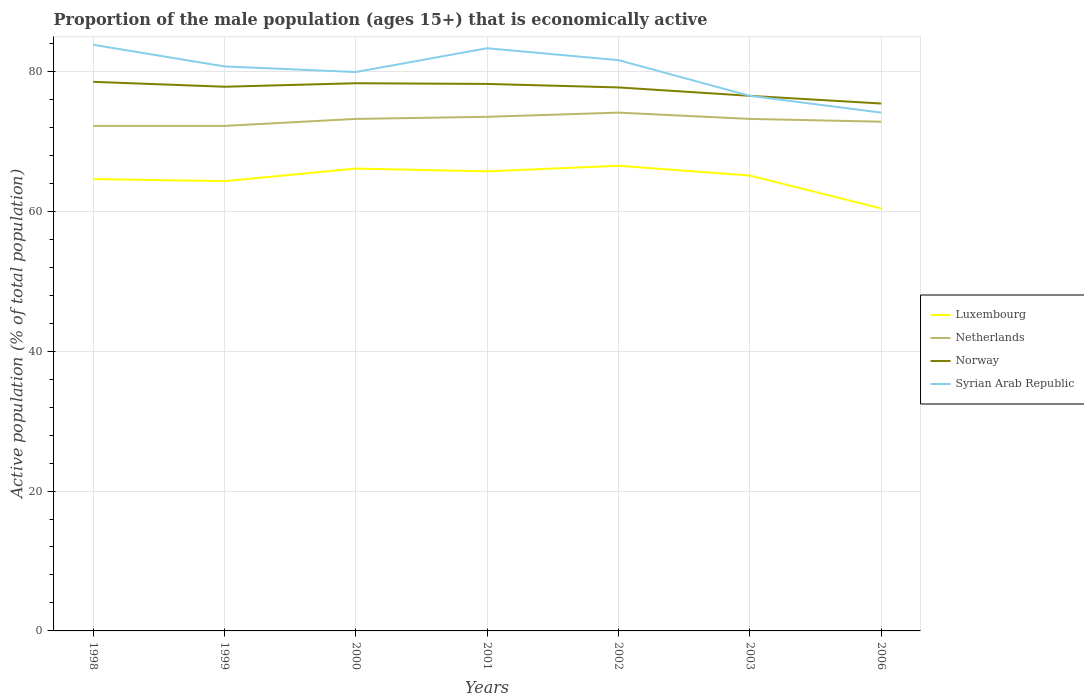How many different coloured lines are there?
Provide a succinct answer. 4. Is the number of lines equal to the number of legend labels?
Your answer should be compact. Yes. Across all years, what is the maximum proportion of the male population that is economically active in Netherlands?
Provide a short and direct response. 72.2. In which year was the proportion of the male population that is economically active in Syrian Arab Republic maximum?
Your response must be concise. 2006. What is the total proportion of the male population that is economically active in Syrian Arab Republic in the graph?
Your response must be concise. -3.4. What is the difference between the highest and the second highest proportion of the male population that is economically active in Luxembourg?
Keep it short and to the point. 6.1. How many lines are there?
Your response must be concise. 4. How many years are there in the graph?
Offer a very short reply. 7. What is the difference between two consecutive major ticks on the Y-axis?
Give a very brief answer. 20. Does the graph contain any zero values?
Offer a terse response. No. Does the graph contain grids?
Offer a terse response. Yes. How many legend labels are there?
Your answer should be compact. 4. What is the title of the graph?
Your answer should be compact. Proportion of the male population (ages 15+) that is economically active. Does "Palau" appear as one of the legend labels in the graph?
Offer a terse response. No. What is the label or title of the Y-axis?
Make the answer very short. Active population (% of total population). What is the Active population (% of total population) in Luxembourg in 1998?
Offer a very short reply. 64.6. What is the Active population (% of total population) of Netherlands in 1998?
Offer a very short reply. 72.2. What is the Active population (% of total population) of Norway in 1998?
Your response must be concise. 78.5. What is the Active population (% of total population) of Syrian Arab Republic in 1998?
Make the answer very short. 83.8. What is the Active population (% of total population) of Luxembourg in 1999?
Keep it short and to the point. 64.3. What is the Active population (% of total population) of Netherlands in 1999?
Ensure brevity in your answer.  72.2. What is the Active population (% of total population) in Norway in 1999?
Ensure brevity in your answer.  77.8. What is the Active population (% of total population) of Syrian Arab Republic in 1999?
Make the answer very short. 80.7. What is the Active population (% of total population) in Luxembourg in 2000?
Make the answer very short. 66.1. What is the Active population (% of total population) of Netherlands in 2000?
Your answer should be compact. 73.2. What is the Active population (% of total population) in Norway in 2000?
Offer a terse response. 78.3. What is the Active population (% of total population) of Syrian Arab Republic in 2000?
Your response must be concise. 79.9. What is the Active population (% of total population) of Luxembourg in 2001?
Give a very brief answer. 65.7. What is the Active population (% of total population) of Netherlands in 2001?
Ensure brevity in your answer.  73.5. What is the Active population (% of total population) of Norway in 2001?
Make the answer very short. 78.2. What is the Active population (% of total population) of Syrian Arab Republic in 2001?
Your response must be concise. 83.3. What is the Active population (% of total population) in Luxembourg in 2002?
Your answer should be very brief. 66.5. What is the Active population (% of total population) of Netherlands in 2002?
Ensure brevity in your answer.  74.1. What is the Active population (% of total population) of Norway in 2002?
Ensure brevity in your answer.  77.7. What is the Active population (% of total population) in Syrian Arab Republic in 2002?
Your response must be concise. 81.6. What is the Active population (% of total population) in Luxembourg in 2003?
Your answer should be compact. 65.1. What is the Active population (% of total population) in Netherlands in 2003?
Give a very brief answer. 73.2. What is the Active population (% of total population) in Norway in 2003?
Your response must be concise. 76.5. What is the Active population (% of total population) of Syrian Arab Republic in 2003?
Offer a very short reply. 76.5. What is the Active population (% of total population) in Luxembourg in 2006?
Ensure brevity in your answer.  60.4. What is the Active population (% of total population) of Netherlands in 2006?
Your answer should be very brief. 72.8. What is the Active population (% of total population) in Norway in 2006?
Your answer should be very brief. 75.4. What is the Active population (% of total population) in Syrian Arab Republic in 2006?
Ensure brevity in your answer.  74.1. Across all years, what is the maximum Active population (% of total population) of Luxembourg?
Ensure brevity in your answer.  66.5. Across all years, what is the maximum Active population (% of total population) of Netherlands?
Provide a short and direct response. 74.1. Across all years, what is the maximum Active population (% of total population) of Norway?
Provide a short and direct response. 78.5. Across all years, what is the maximum Active population (% of total population) of Syrian Arab Republic?
Keep it short and to the point. 83.8. Across all years, what is the minimum Active population (% of total population) of Luxembourg?
Offer a very short reply. 60.4. Across all years, what is the minimum Active population (% of total population) of Netherlands?
Keep it short and to the point. 72.2. Across all years, what is the minimum Active population (% of total population) of Norway?
Give a very brief answer. 75.4. Across all years, what is the minimum Active population (% of total population) of Syrian Arab Republic?
Offer a terse response. 74.1. What is the total Active population (% of total population) in Luxembourg in the graph?
Your answer should be compact. 452.7. What is the total Active population (% of total population) in Netherlands in the graph?
Offer a very short reply. 511.2. What is the total Active population (% of total population) in Norway in the graph?
Your answer should be compact. 542.4. What is the total Active population (% of total population) in Syrian Arab Republic in the graph?
Provide a short and direct response. 559.9. What is the difference between the Active population (% of total population) in Luxembourg in 1998 and that in 1999?
Provide a succinct answer. 0.3. What is the difference between the Active population (% of total population) of Netherlands in 1998 and that in 1999?
Keep it short and to the point. 0. What is the difference between the Active population (% of total population) in Syrian Arab Republic in 1998 and that in 1999?
Provide a short and direct response. 3.1. What is the difference between the Active population (% of total population) in Luxembourg in 1998 and that in 2000?
Offer a very short reply. -1.5. What is the difference between the Active population (% of total population) of Netherlands in 1998 and that in 2000?
Offer a very short reply. -1. What is the difference between the Active population (% of total population) in Luxembourg in 1998 and that in 2001?
Your response must be concise. -1.1. What is the difference between the Active population (% of total population) in Netherlands in 1998 and that in 2001?
Your response must be concise. -1.3. What is the difference between the Active population (% of total population) of Norway in 1998 and that in 2001?
Your response must be concise. 0.3. What is the difference between the Active population (% of total population) of Luxembourg in 1998 and that in 2002?
Make the answer very short. -1.9. What is the difference between the Active population (% of total population) in Netherlands in 1998 and that in 2002?
Offer a very short reply. -1.9. What is the difference between the Active population (% of total population) of Norway in 1998 and that in 2002?
Keep it short and to the point. 0.8. What is the difference between the Active population (% of total population) of Netherlands in 1998 and that in 2003?
Provide a succinct answer. -1. What is the difference between the Active population (% of total population) in Syrian Arab Republic in 1998 and that in 2003?
Your response must be concise. 7.3. What is the difference between the Active population (% of total population) in Netherlands in 1998 and that in 2006?
Offer a very short reply. -0.6. What is the difference between the Active population (% of total population) in Norway in 1998 and that in 2006?
Your response must be concise. 3.1. What is the difference between the Active population (% of total population) of Netherlands in 1999 and that in 2000?
Your answer should be compact. -1. What is the difference between the Active population (% of total population) in Syrian Arab Republic in 1999 and that in 2000?
Offer a terse response. 0.8. What is the difference between the Active population (% of total population) of Luxembourg in 1999 and that in 2001?
Your answer should be very brief. -1.4. What is the difference between the Active population (% of total population) in Netherlands in 1999 and that in 2001?
Offer a very short reply. -1.3. What is the difference between the Active population (% of total population) of Syrian Arab Republic in 1999 and that in 2001?
Your response must be concise. -2.6. What is the difference between the Active population (% of total population) of Netherlands in 1999 and that in 2002?
Give a very brief answer. -1.9. What is the difference between the Active population (% of total population) in Norway in 1999 and that in 2002?
Offer a very short reply. 0.1. What is the difference between the Active population (% of total population) in Netherlands in 1999 and that in 2003?
Offer a terse response. -1. What is the difference between the Active population (% of total population) of Syrian Arab Republic in 1999 and that in 2003?
Provide a succinct answer. 4.2. What is the difference between the Active population (% of total population) in Netherlands in 1999 and that in 2006?
Provide a succinct answer. -0.6. What is the difference between the Active population (% of total population) of Norway in 1999 and that in 2006?
Your answer should be compact. 2.4. What is the difference between the Active population (% of total population) in Syrian Arab Republic in 1999 and that in 2006?
Make the answer very short. 6.6. What is the difference between the Active population (% of total population) in Luxembourg in 2000 and that in 2001?
Offer a very short reply. 0.4. What is the difference between the Active population (% of total population) of Netherlands in 2000 and that in 2001?
Ensure brevity in your answer.  -0.3. What is the difference between the Active population (% of total population) in Norway in 2000 and that in 2001?
Your answer should be compact. 0.1. What is the difference between the Active population (% of total population) in Syrian Arab Republic in 2000 and that in 2001?
Ensure brevity in your answer.  -3.4. What is the difference between the Active population (% of total population) of Luxembourg in 2000 and that in 2002?
Keep it short and to the point. -0.4. What is the difference between the Active population (% of total population) in Netherlands in 2000 and that in 2002?
Offer a terse response. -0.9. What is the difference between the Active population (% of total population) in Syrian Arab Republic in 2000 and that in 2002?
Provide a short and direct response. -1.7. What is the difference between the Active population (% of total population) in Norway in 2000 and that in 2003?
Make the answer very short. 1.8. What is the difference between the Active population (% of total population) in Syrian Arab Republic in 2000 and that in 2003?
Ensure brevity in your answer.  3.4. What is the difference between the Active population (% of total population) of Syrian Arab Republic in 2000 and that in 2006?
Keep it short and to the point. 5.8. What is the difference between the Active population (% of total population) of Luxembourg in 2001 and that in 2002?
Offer a terse response. -0.8. What is the difference between the Active population (% of total population) in Luxembourg in 2001 and that in 2003?
Offer a terse response. 0.6. What is the difference between the Active population (% of total population) of Netherlands in 2001 and that in 2003?
Your answer should be very brief. 0.3. What is the difference between the Active population (% of total population) of Syrian Arab Republic in 2001 and that in 2003?
Your answer should be very brief. 6.8. What is the difference between the Active population (% of total population) of Luxembourg in 2001 and that in 2006?
Your answer should be very brief. 5.3. What is the difference between the Active population (% of total population) of Netherlands in 2001 and that in 2006?
Offer a very short reply. 0.7. What is the difference between the Active population (% of total population) of Syrian Arab Republic in 2001 and that in 2006?
Your answer should be compact. 9.2. What is the difference between the Active population (% of total population) in Netherlands in 2002 and that in 2003?
Offer a terse response. 0.9. What is the difference between the Active population (% of total population) in Norway in 2002 and that in 2003?
Ensure brevity in your answer.  1.2. What is the difference between the Active population (% of total population) of Luxembourg in 2002 and that in 2006?
Offer a very short reply. 6.1. What is the difference between the Active population (% of total population) in Netherlands in 2002 and that in 2006?
Your answer should be compact. 1.3. What is the difference between the Active population (% of total population) in Luxembourg in 2003 and that in 2006?
Make the answer very short. 4.7. What is the difference between the Active population (% of total population) of Syrian Arab Republic in 2003 and that in 2006?
Your answer should be very brief. 2.4. What is the difference between the Active population (% of total population) of Luxembourg in 1998 and the Active population (% of total population) of Norway in 1999?
Ensure brevity in your answer.  -13.2. What is the difference between the Active population (% of total population) of Luxembourg in 1998 and the Active population (% of total population) of Syrian Arab Republic in 1999?
Offer a very short reply. -16.1. What is the difference between the Active population (% of total population) in Netherlands in 1998 and the Active population (% of total population) in Syrian Arab Republic in 1999?
Give a very brief answer. -8.5. What is the difference between the Active population (% of total population) of Luxembourg in 1998 and the Active population (% of total population) of Norway in 2000?
Offer a very short reply. -13.7. What is the difference between the Active population (% of total population) in Luxembourg in 1998 and the Active population (% of total population) in Syrian Arab Republic in 2000?
Make the answer very short. -15.3. What is the difference between the Active population (% of total population) in Netherlands in 1998 and the Active population (% of total population) in Norway in 2000?
Your answer should be compact. -6.1. What is the difference between the Active population (% of total population) of Norway in 1998 and the Active population (% of total population) of Syrian Arab Republic in 2000?
Ensure brevity in your answer.  -1.4. What is the difference between the Active population (% of total population) in Luxembourg in 1998 and the Active population (% of total population) in Norway in 2001?
Offer a very short reply. -13.6. What is the difference between the Active population (% of total population) of Luxembourg in 1998 and the Active population (% of total population) of Syrian Arab Republic in 2001?
Ensure brevity in your answer.  -18.7. What is the difference between the Active population (% of total population) in Norway in 1998 and the Active population (% of total population) in Syrian Arab Republic in 2001?
Provide a succinct answer. -4.8. What is the difference between the Active population (% of total population) of Netherlands in 1998 and the Active population (% of total population) of Syrian Arab Republic in 2002?
Provide a short and direct response. -9.4. What is the difference between the Active population (% of total population) in Norway in 1998 and the Active population (% of total population) in Syrian Arab Republic in 2002?
Ensure brevity in your answer.  -3.1. What is the difference between the Active population (% of total population) of Luxembourg in 1998 and the Active population (% of total population) of Netherlands in 2003?
Your answer should be compact. -8.6. What is the difference between the Active population (% of total population) in Luxembourg in 1998 and the Active population (% of total population) in Norway in 2003?
Offer a terse response. -11.9. What is the difference between the Active population (% of total population) of Netherlands in 1998 and the Active population (% of total population) of Norway in 2006?
Provide a short and direct response. -3.2. What is the difference between the Active population (% of total population) of Netherlands in 1998 and the Active population (% of total population) of Syrian Arab Republic in 2006?
Your response must be concise. -1.9. What is the difference between the Active population (% of total population) of Luxembourg in 1999 and the Active population (% of total population) of Norway in 2000?
Your answer should be compact. -14. What is the difference between the Active population (% of total population) of Luxembourg in 1999 and the Active population (% of total population) of Syrian Arab Republic in 2000?
Your response must be concise. -15.6. What is the difference between the Active population (% of total population) of Netherlands in 1999 and the Active population (% of total population) of Norway in 2000?
Provide a short and direct response. -6.1. What is the difference between the Active population (% of total population) of Netherlands in 1999 and the Active population (% of total population) of Syrian Arab Republic in 2000?
Offer a very short reply. -7.7. What is the difference between the Active population (% of total population) of Norway in 1999 and the Active population (% of total population) of Syrian Arab Republic in 2000?
Make the answer very short. -2.1. What is the difference between the Active population (% of total population) in Luxembourg in 1999 and the Active population (% of total population) in Netherlands in 2001?
Your answer should be compact. -9.2. What is the difference between the Active population (% of total population) of Luxembourg in 1999 and the Active population (% of total population) of Norway in 2001?
Make the answer very short. -13.9. What is the difference between the Active population (% of total population) in Luxembourg in 1999 and the Active population (% of total population) in Syrian Arab Republic in 2001?
Offer a terse response. -19. What is the difference between the Active population (% of total population) in Netherlands in 1999 and the Active population (% of total population) in Norway in 2001?
Provide a succinct answer. -6. What is the difference between the Active population (% of total population) in Norway in 1999 and the Active population (% of total population) in Syrian Arab Republic in 2001?
Ensure brevity in your answer.  -5.5. What is the difference between the Active population (% of total population) of Luxembourg in 1999 and the Active population (% of total population) of Norway in 2002?
Keep it short and to the point. -13.4. What is the difference between the Active population (% of total population) of Luxembourg in 1999 and the Active population (% of total population) of Syrian Arab Republic in 2002?
Offer a terse response. -17.3. What is the difference between the Active population (% of total population) in Netherlands in 1999 and the Active population (% of total population) in Syrian Arab Republic in 2002?
Make the answer very short. -9.4. What is the difference between the Active population (% of total population) in Netherlands in 1999 and the Active population (% of total population) in Syrian Arab Republic in 2003?
Ensure brevity in your answer.  -4.3. What is the difference between the Active population (% of total population) of Norway in 1999 and the Active population (% of total population) of Syrian Arab Republic in 2003?
Offer a terse response. 1.3. What is the difference between the Active population (% of total population) of Netherlands in 1999 and the Active population (% of total population) of Norway in 2006?
Provide a short and direct response. -3.2. What is the difference between the Active population (% of total population) of Netherlands in 1999 and the Active population (% of total population) of Syrian Arab Republic in 2006?
Make the answer very short. -1.9. What is the difference between the Active population (% of total population) of Luxembourg in 2000 and the Active population (% of total population) of Norway in 2001?
Provide a short and direct response. -12.1. What is the difference between the Active population (% of total population) of Luxembourg in 2000 and the Active population (% of total population) of Syrian Arab Republic in 2001?
Provide a short and direct response. -17.2. What is the difference between the Active population (% of total population) of Netherlands in 2000 and the Active population (% of total population) of Norway in 2001?
Make the answer very short. -5. What is the difference between the Active population (% of total population) in Norway in 2000 and the Active population (% of total population) in Syrian Arab Republic in 2001?
Offer a terse response. -5. What is the difference between the Active population (% of total population) in Luxembourg in 2000 and the Active population (% of total population) in Netherlands in 2002?
Offer a terse response. -8. What is the difference between the Active population (% of total population) in Luxembourg in 2000 and the Active population (% of total population) in Norway in 2002?
Your answer should be compact. -11.6. What is the difference between the Active population (% of total population) in Luxembourg in 2000 and the Active population (% of total population) in Syrian Arab Republic in 2002?
Provide a short and direct response. -15.5. What is the difference between the Active population (% of total population) in Norway in 2000 and the Active population (% of total population) in Syrian Arab Republic in 2002?
Offer a terse response. -3.3. What is the difference between the Active population (% of total population) of Norway in 2000 and the Active population (% of total population) of Syrian Arab Republic in 2003?
Offer a terse response. 1.8. What is the difference between the Active population (% of total population) of Luxembourg in 2000 and the Active population (% of total population) of Netherlands in 2006?
Make the answer very short. -6.7. What is the difference between the Active population (% of total population) of Netherlands in 2000 and the Active population (% of total population) of Norway in 2006?
Offer a very short reply. -2.2. What is the difference between the Active population (% of total population) in Netherlands in 2000 and the Active population (% of total population) in Syrian Arab Republic in 2006?
Offer a terse response. -0.9. What is the difference between the Active population (% of total population) in Norway in 2000 and the Active population (% of total population) in Syrian Arab Republic in 2006?
Your answer should be very brief. 4.2. What is the difference between the Active population (% of total population) in Luxembourg in 2001 and the Active population (% of total population) in Netherlands in 2002?
Keep it short and to the point. -8.4. What is the difference between the Active population (% of total population) in Luxembourg in 2001 and the Active population (% of total population) in Norway in 2002?
Give a very brief answer. -12. What is the difference between the Active population (% of total population) of Luxembourg in 2001 and the Active population (% of total population) of Syrian Arab Republic in 2002?
Your answer should be very brief. -15.9. What is the difference between the Active population (% of total population) in Netherlands in 2001 and the Active population (% of total population) in Norway in 2002?
Your response must be concise. -4.2. What is the difference between the Active population (% of total population) of Netherlands in 2001 and the Active population (% of total population) of Syrian Arab Republic in 2002?
Your answer should be compact. -8.1. What is the difference between the Active population (% of total population) of Luxembourg in 2001 and the Active population (% of total population) of Netherlands in 2003?
Offer a very short reply. -7.5. What is the difference between the Active population (% of total population) in Luxembourg in 2001 and the Active population (% of total population) in Norway in 2003?
Your response must be concise. -10.8. What is the difference between the Active population (% of total population) of Luxembourg in 2001 and the Active population (% of total population) of Syrian Arab Republic in 2003?
Provide a succinct answer. -10.8. What is the difference between the Active population (% of total population) in Norway in 2001 and the Active population (% of total population) in Syrian Arab Republic in 2003?
Your answer should be very brief. 1.7. What is the difference between the Active population (% of total population) of Luxembourg in 2001 and the Active population (% of total population) of Norway in 2006?
Offer a terse response. -9.7. What is the difference between the Active population (% of total population) in Luxembourg in 2002 and the Active population (% of total population) in Norway in 2003?
Keep it short and to the point. -10. What is the difference between the Active population (% of total population) of Luxembourg in 2002 and the Active population (% of total population) of Syrian Arab Republic in 2003?
Give a very brief answer. -10. What is the difference between the Active population (% of total population) in Luxembourg in 2002 and the Active population (% of total population) in Netherlands in 2006?
Your response must be concise. -6.3. What is the difference between the Active population (% of total population) of Luxembourg in 2002 and the Active population (% of total population) of Norway in 2006?
Your answer should be very brief. -8.9. What is the difference between the Active population (% of total population) of Netherlands in 2002 and the Active population (% of total population) of Norway in 2006?
Your answer should be compact. -1.3. What is the difference between the Active population (% of total population) of Norway in 2002 and the Active population (% of total population) of Syrian Arab Republic in 2006?
Your answer should be compact. 3.6. What is the difference between the Active population (% of total population) in Luxembourg in 2003 and the Active population (% of total population) in Netherlands in 2006?
Keep it short and to the point. -7.7. What is the difference between the Active population (% of total population) of Luxembourg in 2003 and the Active population (% of total population) of Syrian Arab Republic in 2006?
Provide a short and direct response. -9. What is the difference between the Active population (% of total population) of Norway in 2003 and the Active population (% of total population) of Syrian Arab Republic in 2006?
Make the answer very short. 2.4. What is the average Active population (% of total population) of Luxembourg per year?
Keep it short and to the point. 64.67. What is the average Active population (% of total population) of Netherlands per year?
Keep it short and to the point. 73.03. What is the average Active population (% of total population) in Norway per year?
Provide a short and direct response. 77.49. What is the average Active population (% of total population) of Syrian Arab Republic per year?
Provide a short and direct response. 79.99. In the year 1998, what is the difference between the Active population (% of total population) in Luxembourg and Active population (% of total population) in Netherlands?
Your answer should be compact. -7.6. In the year 1998, what is the difference between the Active population (% of total population) in Luxembourg and Active population (% of total population) in Syrian Arab Republic?
Your response must be concise. -19.2. In the year 1998, what is the difference between the Active population (% of total population) in Netherlands and Active population (% of total population) in Norway?
Your answer should be very brief. -6.3. In the year 1999, what is the difference between the Active population (% of total population) of Luxembourg and Active population (% of total population) of Norway?
Make the answer very short. -13.5. In the year 1999, what is the difference between the Active population (% of total population) in Luxembourg and Active population (% of total population) in Syrian Arab Republic?
Make the answer very short. -16.4. In the year 2000, what is the difference between the Active population (% of total population) in Luxembourg and Active population (% of total population) in Netherlands?
Ensure brevity in your answer.  -7.1. In the year 2000, what is the difference between the Active population (% of total population) in Norway and Active population (% of total population) in Syrian Arab Republic?
Give a very brief answer. -1.6. In the year 2001, what is the difference between the Active population (% of total population) of Luxembourg and Active population (% of total population) of Syrian Arab Republic?
Make the answer very short. -17.6. In the year 2001, what is the difference between the Active population (% of total population) in Netherlands and Active population (% of total population) in Norway?
Offer a very short reply. -4.7. In the year 2001, what is the difference between the Active population (% of total population) in Netherlands and Active population (% of total population) in Syrian Arab Republic?
Keep it short and to the point. -9.8. In the year 2002, what is the difference between the Active population (% of total population) in Luxembourg and Active population (% of total population) in Netherlands?
Ensure brevity in your answer.  -7.6. In the year 2002, what is the difference between the Active population (% of total population) in Luxembourg and Active population (% of total population) in Norway?
Make the answer very short. -11.2. In the year 2002, what is the difference between the Active population (% of total population) of Luxembourg and Active population (% of total population) of Syrian Arab Republic?
Your response must be concise. -15.1. In the year 2002, what is the difference between the Active population (% of total population) in Netherlands and Active population (% of total population) in Norway?
Provide a succinct answer. -3.6. In the year 2002, what is the difference between the Active population (% of total population) of Netherlands and Active population (% of total population) of Syrian Arab Republic?
Your answer should be compact. -7.5. In the year 2003, what is the difference between the Active population (% of total population) in Netherlands and Active population (% of total population) in Norway?
Provide a succinct answer. -3.3. In the year 2003, what is the difference between the Active population (% of total population) of Norway and Active population (% of total population) of Syrian Arab Republic?
Keep it short and to the point. 0. In the year 2006, what is the difference between the Active population (% of total population) in Luxembourg and Active population (% of total population) in Norway?
Keep it short and to the point. -15. In the year 2006, what is the difference between the Active population (% of total population) of Luxembourg and Active population (% of total population) of Syrian Arab Republic?
Ensure brevity in your answer.  -13.7. In the year 2006, what is the difference between the Active population (% of total population) in Netherlands and Active population (% of total population) in Syrian Arab Republic?
Offer a very short reply. -1.3. In the year 2006, what is the difference between the Active population (% of total population) of Norway and Active population (% of total population) of Syrian Arab Republic?
Give a very brief answer. 1.3. What is the ratio of the Active population (% of total population) in Syrian Arab Republic in 1998 to that in 1999?
Provide a succinct answer. 1.04. What is the ratio of the Active population (% of total population) of Luxembourg in 1998 to that in 2000?
Keep it short and to the point. 0.98. What is the ratio of the Active population (% of total population) in Netherlands in 1998 to that in 2000?
Your answer should be very brief. 0.99. What is the ratio of the Active population (% of total population) in Norway in 1998 to that in 2000?
Give a very brief answer. 1. What is the ratio of the Active population (% of total population) in Syrian Arab Republic in 1998 to that in 2000?
Offer a terse response. 1.05. What is the ratio of the Active population (% of total population) of Luxembourg in 1998 to that in 2001?
Your response must be concise. 0.98. What is the ratio of the Active population (% of total population) of Netherlands in 1998 to that in 2001?
Give a very brief answer. 0.98. What is the ratio of the Active population (% of total population) in Norway in 1998 to that in 2001?
Give a very brief answer. 1. What is the ratio of the Active population (% of total population) of Luxembourg in 1998 to that in 2002?
Your response must be concise. 0.97. What is the ratio of the Active population (% of total population) of Netherlands in 1998 to that in 2002?
Your response must be concise. 0.97. What is the ratio of the Active population (% of total population) in Norway in 1998 to that in 2002?
Provide a succinct answer. 1.01. What is the ratio of the Active population (% of total population) in Luxembourg in 1998 to that in 2003?
Your answer should be very brief. 0.99. What is the ratio of the Active population (% of total population) of Netherlands in 1998 to that in 2003?
Provide a short and direct response. 0.99. What is the ratio of the Active population (% of total population) in Norway in 1998 to that in 2003?
Provide a succinct answer. 1.03. What is the ratio of the Active population (% of total population) in Syrian Arab Republic in 1998 to that in 2003?
Keep it short and to the point. 1.1. What is the ratio of the Active population (% of total population) in Luxembourg in 1998 to that in 2006?
Provide a succinct answer. 1.07. What is the ratio of the Active population (% of total population) in Norway in 1998 to that in 2006?
Make the answer very short. 1.04. What is the ratio of the Active population (% of total population) of Syrian Arab Republic in 1998 to that in 2006?
Make the answer very short. 1.13. What is the ratio of the Active population (% of total population) in Luxembourg in 1999 to that in 2000?
Offer a terse response. 0.97. What is the ratio of the Active population (% of total population) of Netherlands in 1999 to that in 2000?
Make the answer very short. 0.99. What is the ratio of the Active population (% of total population) of Luxembourg in 1999 to that in 2001?
Provide a succinct answer. 0.98. What is the ratio of the Active population (% of total population) of Netherlands in 1999 to that in 2001?
Provide a succinct answer. 0.98. What is the ratio of the Active population (% of total population) of Syrian Arab Republic in 1999 to that in 2001?
Your answer should be very brief. 0.97. What is the ratio of the Active population (% of total population) of Luxembourg in 1999 to that in 2002?
Your answer should be compact. 0.97. What is the ratio of the Active population (% of total population) in Netherlands in 1999 to that in 2002?
Your response must be concise. 0.97. What is the ratio of the Active population (% of total population) in Norway in 1999 to that in 2002?
Offer a terse response. 1. What is the ratio of the Active population (% of total population) in Syrian Arab Republic in 1999 to that in 2002?
Your answer should be very brief. 0.99. What is the ratio of the Active population (% of total population) in Netherlands in 1999 to that in 2003?
Offer a very short reply. 0.99. What is the ratio of the Active population (% of total population) in Syrian Arab Republic in 1999 to that in 2003?
Give a very brief answer. 1.05. What is the ratio of the Active population (% of total population) of Luxembourg in 1999 to that in 2006?
Your answer should be very brief. 1.06. What is the ratio of the Active population (% of total population) in Norway in 1999 to that in 2006?
Provide a short and direct response. 1.03. What is the ratio of the Active population (% of total population) of Syrian Arab Republic in 1999 to that in 2006?
Ensure brevity in your answer.  1.09. What is the ratio of the Active population (% of total population) of Netherlands in 2000 to that in 2001?
Give a very brief answer. 1. What is the ratio of the Active population (% of total population) of Norway in 2000 to that in 2001?
Provide a short and direct response. 1. What is the ratio of the Active population (% of total population) of Syrian Arab Republic in 2000 to that in 2001?
Give a very brief answer. 0.96. What is the ratio of the Active population (% of total population) in Netherlands in 2000 to that in 2002?
Make the answer very short. 0.99. What is the ratio of the Active population (% of total population) in Norway in 2000 to that in 2002?
Your response must be concise. 1.01. What is the ratio of the Active population (% of total population) of Syrian Arab Republic in 2000 to that in 2002?
Your answer should be compact. 0.98. What is the ratio of the Active population (% of total population) in Luxembourg in 2000 to that in 2003?
Your response must be concise. 1.02. What is the ratio of the Active population (% of total population) of Norway in 2000 to that in 2003?
Keep it short and to the point. 1.02. What is the ratio of the Active population (% of total population) of Syrian Arab Republic in 2000 to that in 2003?
Keep it short and to the point. 1.04. What is the ratio of the Active population (% of total population) of Luxembourg in 2000 to that in 2006?
Your answer should be compact. 1.09. What is the ratio of the Active population (% of total population) of Norway in 2000 to that in 2006?
Offer a terse response. 1.04. What is the ratio of the Active population (% of total population) in Syrian Arab Republic in 2000 to that in 2006?
Your answer should be compact. 1.08. What is the ratio of the Active population (% of total population) in Luxembourg in 2001 to that in 2002?
Offer a very short reply. 0.99. What is the ratio of the Active population (% of total population) of Netherlands in 2001 to that in 2002?
Keep it short and to the point. 0.99. What is the ratio of the Active population (% of total population) of Norway in 2001 to that in 2002?
Ensure brevity in your answer.  1.01. What is the ratio of the Active population (% of total population) in Syrian Arab Republic in 2001 to that in 2002?
Provide a succinct answer. 1.02. What is the ratio of the Active population (% of total population) of Luxembourg in 2001 to that in 2003?
Ensure brevity in your answer.  1.01. What is the ratio of the Active population (% of total population) of Netherlands in 2001 to that in 2003?
Your answer should be compact. 1. What is the ratio of the Active population (% of total population) in Norway in 2001 to that in 2003?
Offer a very short reply. 1.02. What is the ratio of the Active population (% of total population) of Syrian Arab Republic in 2001 to that in 2003?
Ensure brevity in your answer.  1.09. What is the ratio of the Active population (% of total population) in Luxembourg in 2001 to that in 2006?
Provide a succinct answer. 1.09. What is the ratio of the Active population (% of total population) in Netherlands in 2001 to that in 2006?
Offer a terse response. 1.01. What is the ratio of the Active population (% of total population) of Norway in 2001 to that in 2006?
Provide a short and direct response. 1.04. What is the ratio of the Active population (% of total population) of Syrian Arab Republic in 2001 to that in 2006?
Keep it short and to the point. 1.12. What is the ratio of the Active population (% of total population) of Luxembourg in 2002 to that in 2003?
Offer a terse response. 1.02. What is the ratio of the Active population (% of total population) in Netherlands in 2002 to that in 2003?
Give a very brief answer. 1.01. What is the ratio of the Active population (% of total population) of Norway in 2002 to that in 2003?
Your answer should be very brief. 1.02. What is the ratio of the Active population (% of total population) of Syrian Arab Republic in 2002 to that in 2003?
Provide a short and direct response. 1.07. What is the ratio of the Active population (% of total population) of Luxembourg in 2002 to that in 2006?
Keep it short and to the point. 1.1. What is the ratio of the Active population (% of total population) of Netherlands in 2002 to that in 2006?
Give a very brief answer. 1.02. What is the ratio of the Active population (% of total population) in Norway in 2002 to that in 2006?
Your answer should be very brief. 1.03. What is the ratio of the Active population (% of total population) in Syrian Arab Republic in 2002 to that in 2006?
Offer a terse response. 1.1. What is the ratio of the Active population (% of total population) of Luxembourg in 2003 to that in 2006?
Give a very brief answer. 1.08. What is the ratio of the Active population (% of total population) of Netherlands in 2003 to that in 2006?
Keep it short and to the point. 1.01. What is the ratio of the Active population (% of total population) of Norway in 2003 to that in 2006?
Make the answer very short. 1.01. What is the ratio of the Active population (% of total population) of Syrian Arab Republic in 2003 to that in 2006?
Your answer should be compact. 1.03. What is the difference between the highest and the second highest Active population (% of total population) of Luxembourg?
Your answer should be compact. 0.4. What is the difference between the highest and the second highest Active population (% of total population) of Syrian Arab Republic?
Your answer should be very brief. 0.5. What is the difference between the highest and the lowest Active population (% of total population) of Norway?
Offer a very short reply. 3.1. What is the difference between the highest and the lowest Active population (% of total population) of Syrian Arab Republic?
Offer a very short reply. 9.7. 